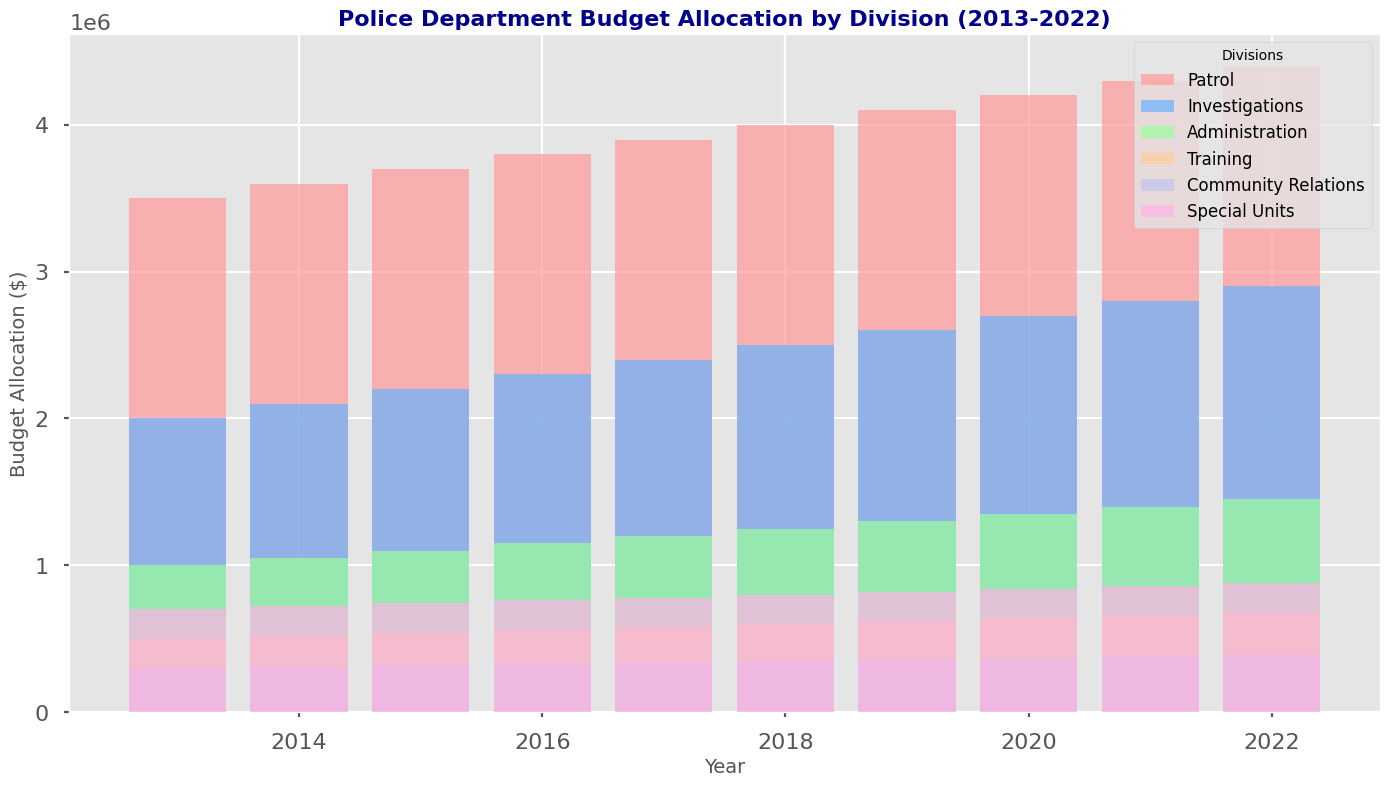Is the budget allocation for the Patrol division in 2022 higher than that in 2013? Compare the height of the bar representing the Patrol division for the years 2013 and 2022. The height for 2022 is higher than for 2013.
Answer: Yes Between which two consecutive years was the budget increase for the Special Units division the largest? Identify the height difference of the bars representing the Special Units division for each consecutive year. The largest difference is observed between 2021 and 2022.
Answer: 2021-2022 How does the budget allocation trend for Community Relations change over the decade? Observe and describe the height of the bars representing Community Relations across all years. The bars show an increasing trend from 2013 to 2022.
Answer: Increasing What is the sum of the budget allocations for Training and Administration in 2018? Find the height of the bars representing Training and Administration in 2018, and sum them up (600,000 + 1,250,000).
Answer: 1,850,000 Which division had the smallest increase in budget allocation from 2013 to 2018? Calculate the difference in the height of the bar for each division between 2013 and 2018. The smallest increase is for Community Relations (350,000 - 300,000 = 50,000).
Answer: Community Relations What was the budget allocation difference between Investigations and Training in 2020? Find the height of the bars representing Investigations and Training in 2020, and calculate the difference (2,700,000 - 640,000).
Answer: 2,060,000 In which year did the Patrol division first exceed a budget allocation of $4,000,000? Identify the year where the height of the bar for the Patrol division first exceeds $4,000,000. This happens in 2018.
Answer: 2018 How many years did the Training division's budget remain below $600,000? Observe and count the years where the bar for the Training division is below the $600,000 mark. This occurs in 2013, 2014, and 2015.
Answer: 3 years 